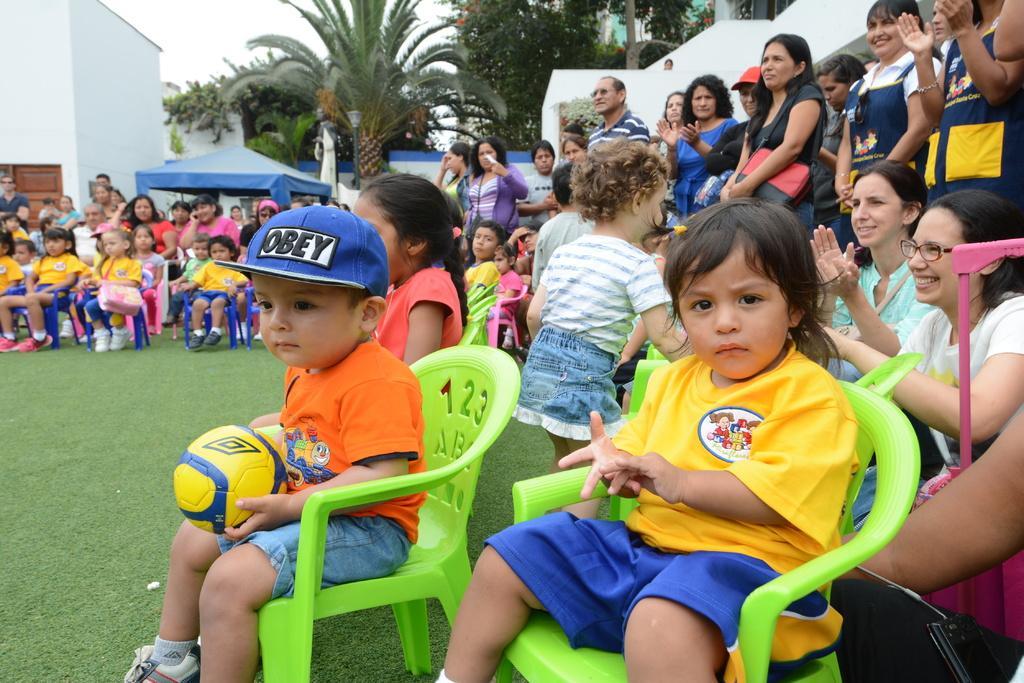Could you give a brief overview of what you see in this image? Here we can see a group of children are sitting on the chair, and at back a group of persons are standing on the grass, and here are the trees, and here is the sky. 